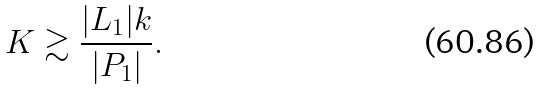<formula> <loc_0><loc_0><loc_500><loc_500>K \gtrsim \frac { | L _ { 1 } | k } { | P _ { 1 } | } .</formula> 